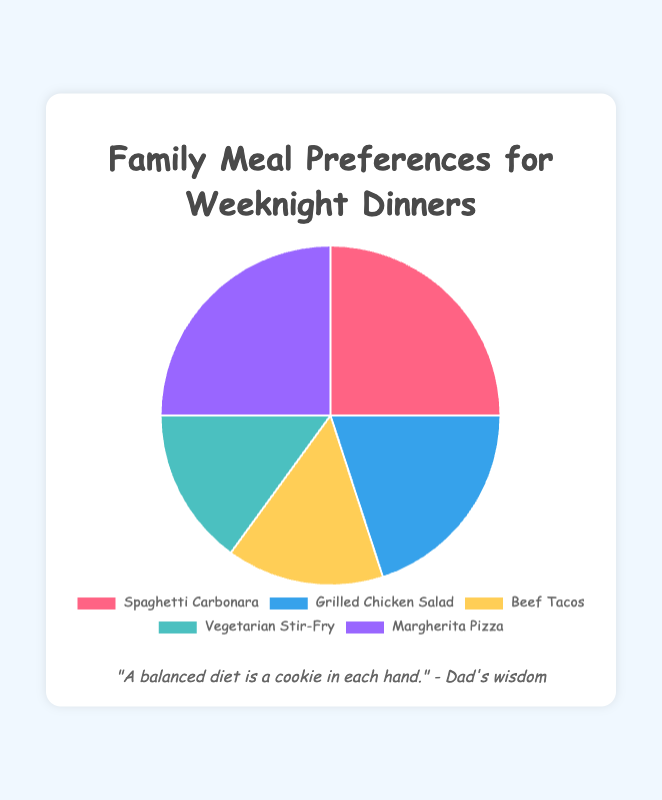Which meals have the highest preference percentage? Looking at the chart, we can see that Spaghetti Carbonara and Margherita Pizza have the largest slices at 25% each, indicating they have the highest preference.
Answer: Spaghetti Carbonara and Margherita Pizza What's the total percentage of the least preferred meals? The least preferred meals are Beef Tacos and Vegetarian Stir-Fry, each with 15%. Adding these percentages together gives us 15% + 15% = 30%.
Answer: 30% How does the preference for Grilled Chicken Salad compare to Beef Tacos? Grilled Chicken Salad has a preference percentage of 20%, while Beef Tacos have 15%. Therefore, Grilled Chicken Salad is more preferred by a difference of 5%.
Answer: Grilled Chicken Salad is 5% more preferred What is the average preference percentage of all meals? Adding all preference percentages (25 + 20 + 15 + 15 + 25) gives us 100%. Dividing this by the number of meals (5) gives us an average of 100% / 5 = 20%.
Answer: 20% Which meal is represented by the light blue slice in the chart? Observing the colors, the light blue slice corresponds to Grilled Chicken Salad's 20% preference.
Answer: Grilled Chicken Salad If Margherita Pizza's preference dropped by 10%, which meal would then be the most preferred? Currently, Margherita Pizza has 25%. If it dropped by 10%, it would be 15%. The highest would then be Spaghetti Carbonara with 25%.
Answer: Spaghetti Carbonara How much more preferred is the most preferred meal compared to the least preferred meals? The most preferred meals, Spaghetti Carbonara and Margherita Pizza, each have 25%. The least preferred meals, Beef Tacos and Vegetarian Stir-Fry, each have 15%. 25% - 15% = 10%.
Answer: 10% more preferred What is the percentage difference between Spaghetti Carbonara and Vegetarian Stir-Fry? Spaghetti Carbonara has 25% preference, and Vegetarian Stir-Fry has 15%. The difference is 25% - 15% = 10%.
Answer: 10% What color represents Spaghetti Carbonara in the pie chart? By looking at the colors associated with each slice, Spaghetti Carbonara is represented in red.
Answer: Red Is there any meal that holds equal preference percentages with another meal? Yes, both Beef Tacos and Vegetarian Stir-Fry each have a preference percentage of 15%.
Answer: Yes Comparing the sum of preferences of the top two meals to the sum of preferences for the bottom two meals, which is greater? The top two meals (Spaghetti Carbonara and Margherita Pizza) sum up to 25% + 25% = 50%. The bottom two meals (Beef Tacos and Vegetarian Stir-Fry) sum up to 15% + 15% = 30%. Hence, 50% is greater than 30%.
Answer: Top two meals are greater 